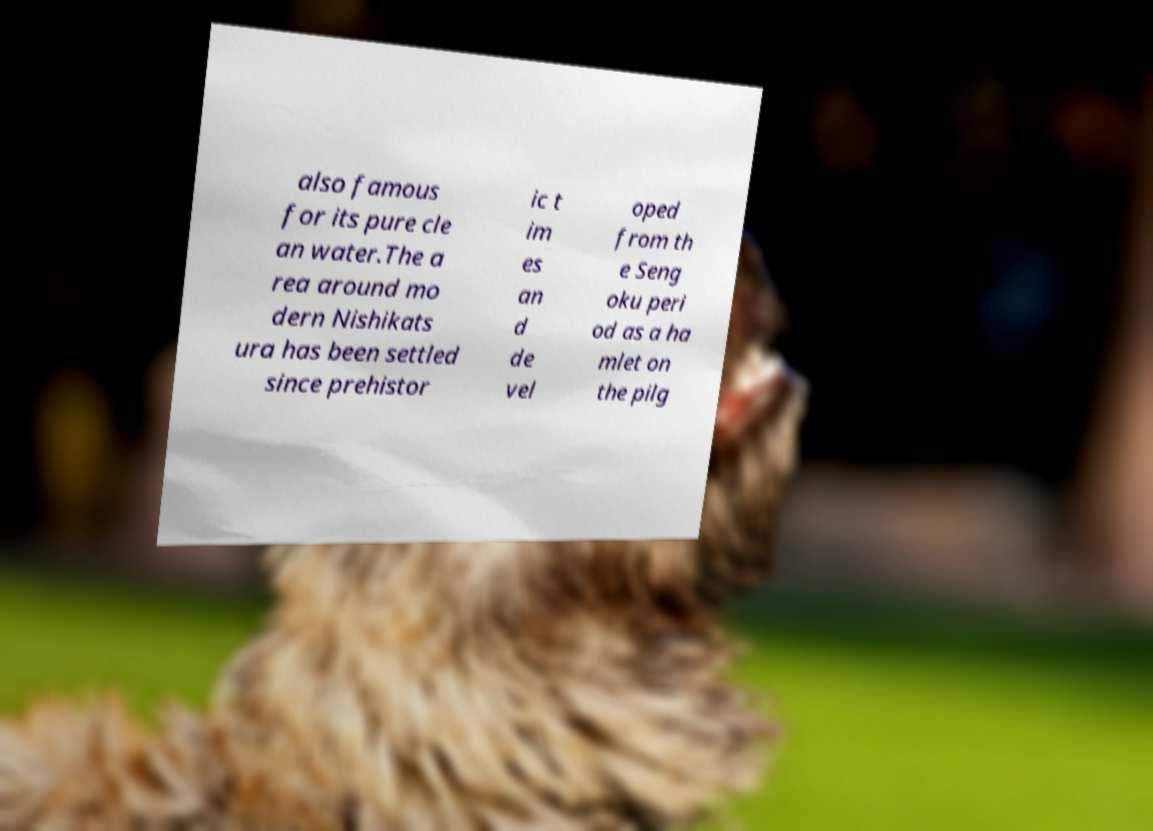What messages or text are displayed in this image? I need them in a readable, typed format. also famous for its pure cle an water.The a rea around mo dern Nishikats ura has been settled since prehistor ic t im es an d de vel oped from th e Seng oku peri od as a ha mlet on the pilg 